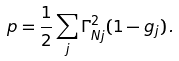<formula> <loc_0><loc_0><loc_500><loc_500>p = \frac { 1 } { 2 } \sum _ { j } \Gamma _ { N j } ^ { 2 } ( 1 - g _ { j } ) \, .</formula> 